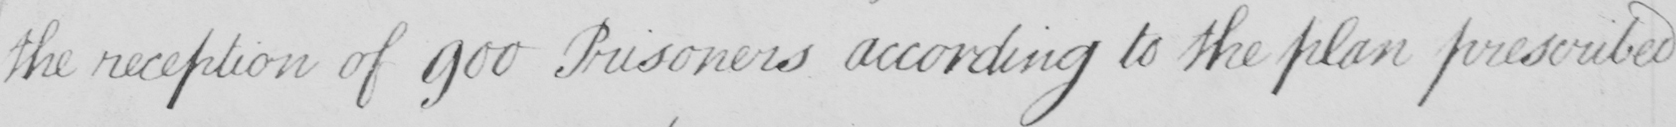What does this handwritten line say? the reception of 900 Prisoners according to the plan prescribed 